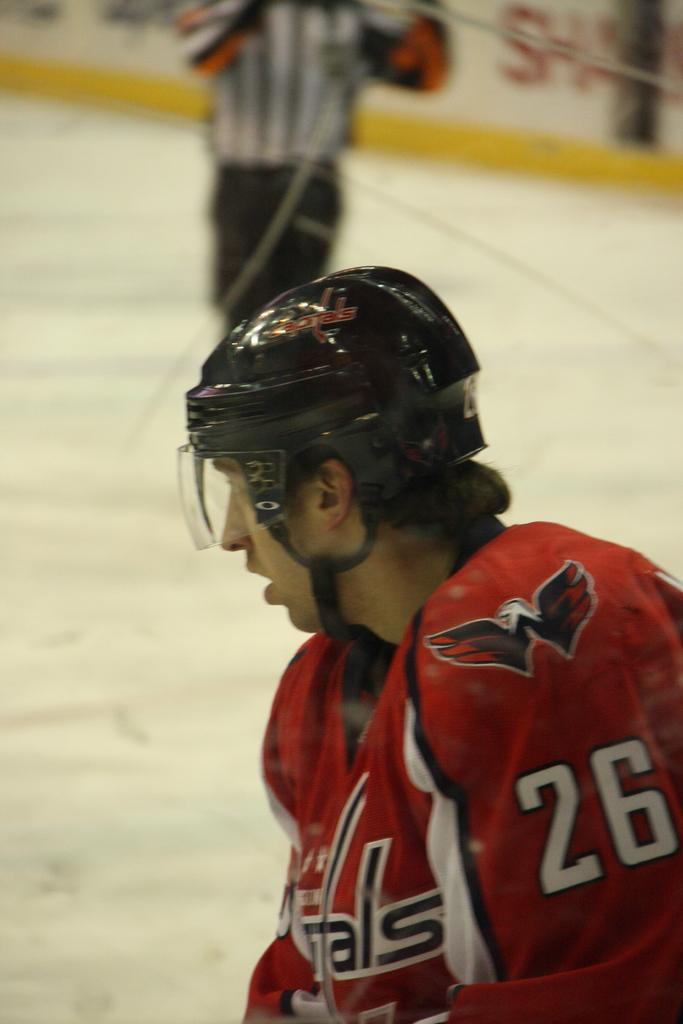What is the person in the image wearing on their head? The person in the image is wearing a helmet. What can be seen in the background of the image? There is a referee and an advertisement in the background of the image. What is the effect of the mother's presence on the person wearing a helmet in the image? There is no mention of a mother in the image, so it is not possible to determine the effect of her presence. 